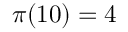<formula> <loc_0><loc_0><loc_500><loc_500>\pi ( 1 0 ) = 4</formula> 